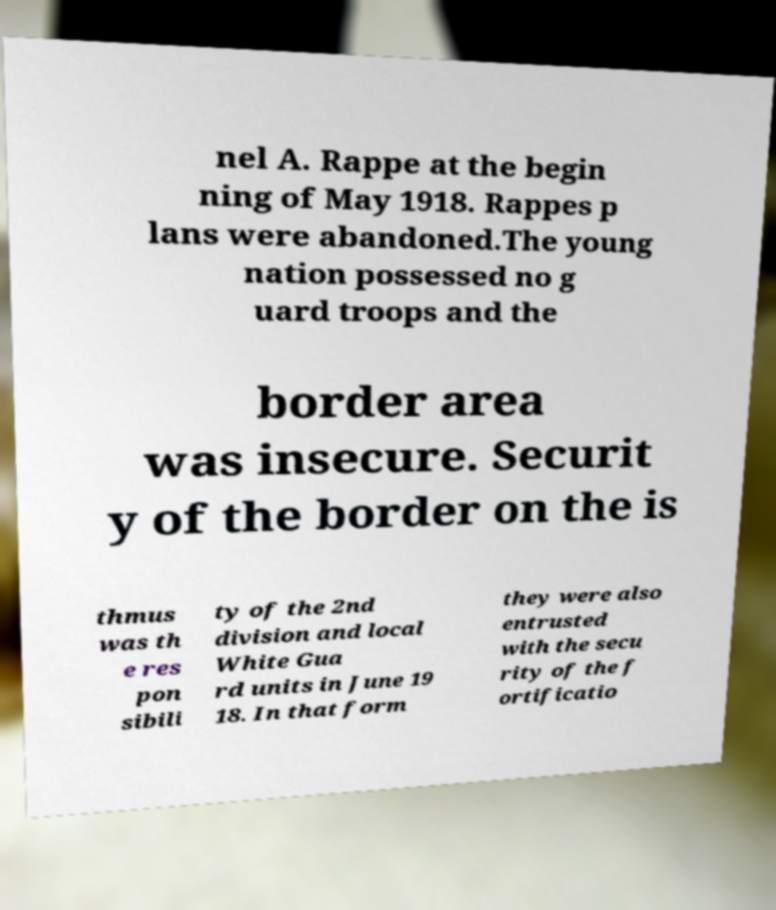Could you assist in decoding the text presented in this image and type it out clearly? nel A. Rappe at the begin ning of May 1918. Rappes p lans were abandoned.The young nation possessed no g uard troops and the border area was insecure. Securit y of the border on the is thmus was th e res pon sibili ty of the 2nd division and local White Gua rd units in June 19 18. In that form they were also entrusted with the secu rity of the f ortificatio 